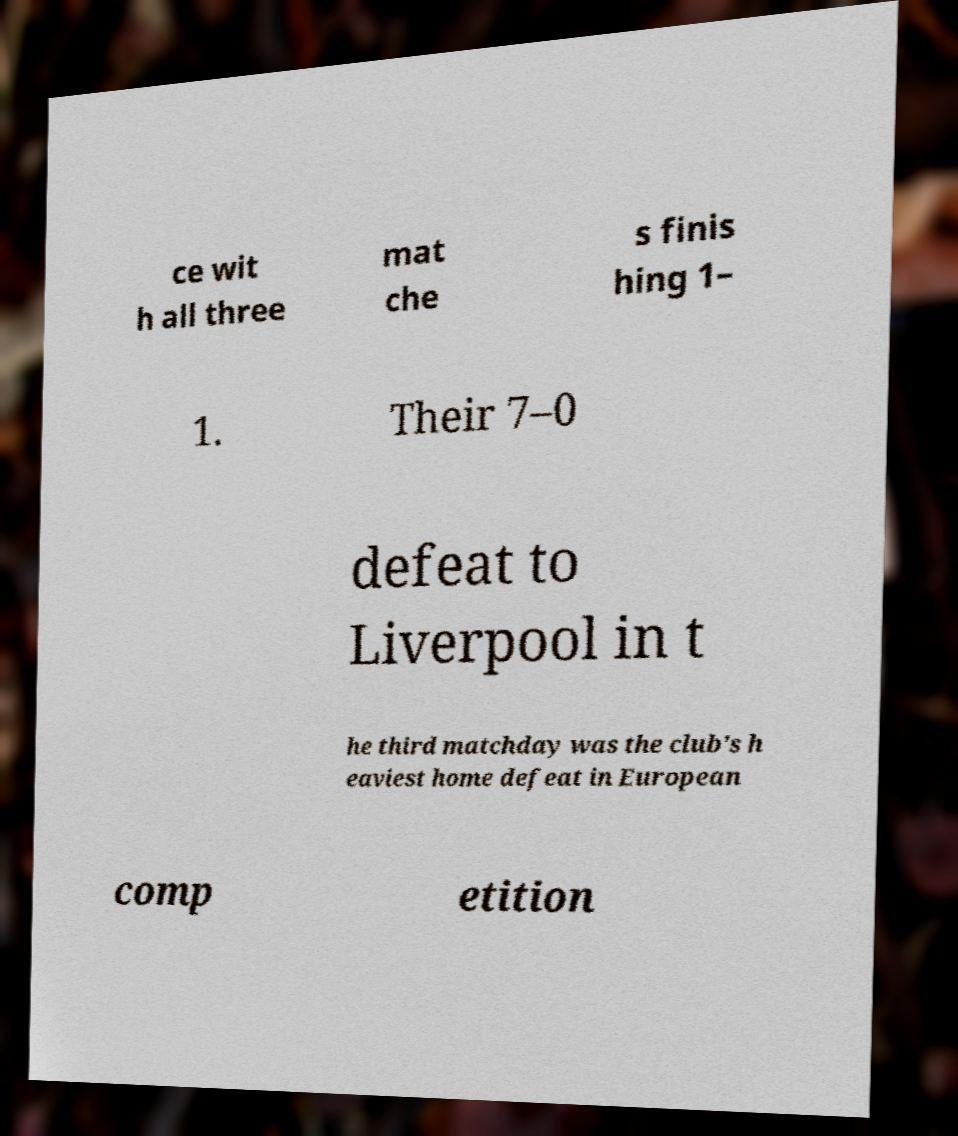For documentation purposes, I need the text within this image transcribed. Could you provide that? ce wit h all three mat che s finis hing 1– 1. Their 7–0 defeat to Liverpool in t he third matchday was the club's h eaviest home defeat in European comp etition 